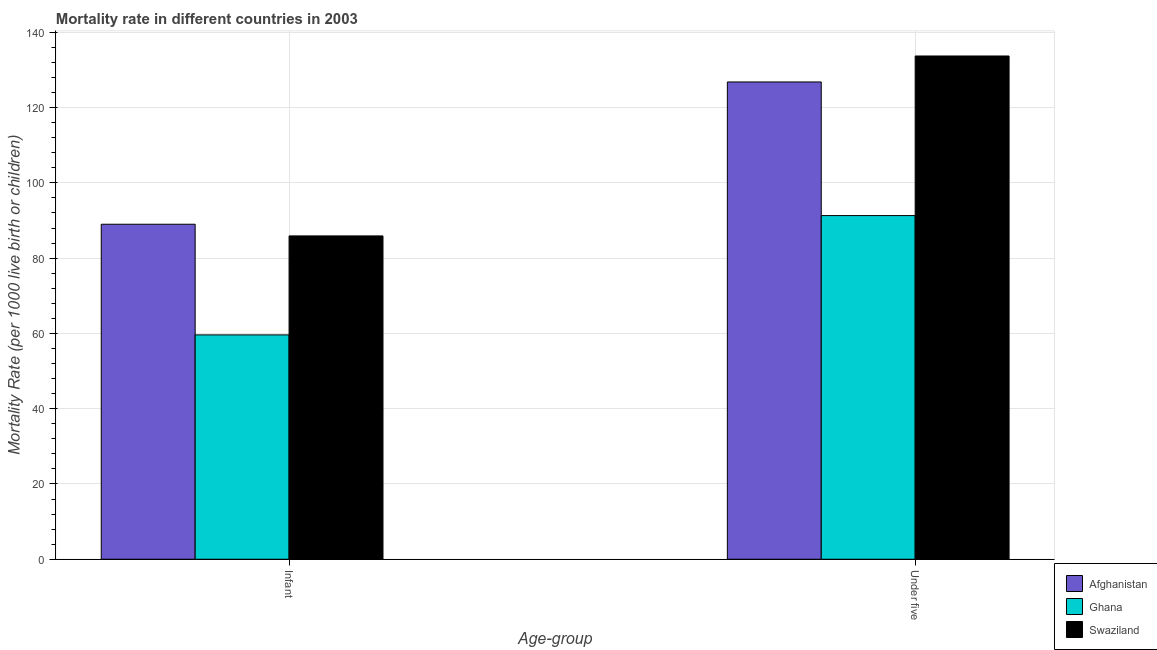How many different coloured bars are there?
Give a very brief answer. 3. Are the number of bars on each tick of the X-axis equal?
Offer a very short reply. Yes. How many bars are there on the 2nd tick from the left?
Ensure brevity in your answer.  3. How many bars are there on the 2nd tick from the right?
Your answer should be compact. 3. What is the label of the 1st group of bars from the left?
Give a very brief answer. Infant. What is the infant mortality rate in Ghana?
Your response must be concise. 59.6. Across all countries, what is the maximum under-5 mortality rate?
Offer a terse response. 133.7. Across all countries, what is the minimum infant mortality rate?
Offer a very short reply. 59.6. In which country was the under-5 mortality rate maximum?
Your answer should be compact. Swaziland. In which country was the infant mortality rate minimum?
Keep it short and to the point. Ghana. What is the total under-5 mortality rate in the graph?
Your response must be concise. 351.8. What is the difference between the infant mortality rate in Afghanistan and that in Ghana?
Your answer should be compact. 29.4. What is the difference between the infant mortality rate in Afghanistan and the under-5 mortality rate in Swaziland?
Ensure brevity in your answer.  -44.7. What is the average under-5 mortality rate per country?
Your answer should be very brief. 117.27. What is the difference between the under-5 mortality rate and infant mortality rate in Ghana?
Your answer should be compact. 31.7. In how many countries, is the under-5 mortality rate greater than 48 ?
Keep it short and to the point. 3. What is the ratio of the under-5 mortality rate in Swaziland to that in Afghanistan?
Provide a succinct answer. 1.05. Is the infant mortality rate in Ghana less than that in Afghanistan?
Make the answer very short. Yes. In how many countries, is the under-5 mortality rate greater than the average under-5 mortality rate taken over all countries?
Provide a short and direct response. 2. What does the 3rd bar from the left in Under five represents?
Keep it short and to the point. Swaziland. What does the 1st bar from the right in Under five represents?
Keep it short and to the point. Swaziland. How many bars are there?
Give a very brief answer. 6. Are all the bars in the graph horizontal?
Ensure brevity in your answer.  No. How many countries are there in the graph?
Offer a terse response. 3. What is the difference between two consecutive major ticks on the Y-axis?
Your response must be concise. 20. Does the graph contain any zero values?
Give a very brief answer. No. Does the graph contain grids?
Give a very brief answer. Yes. What is the title of the graph?
Provide a succinct answer. Mortality rate in different countries in 2003. Does "Italy" appear as one of the legend labels in the graph?
Give a very brief answer. No. What is the label or title of the X-axis?
Give a very brief answer. Age-group. What is the label or title of the Y-axis?
Provide a succinct answer. Mortality Rate (per 1000 live birth or children). What is the Mortality Rate (per 1000 live birth or children) of Afghanistan in Infant?
Ensure brevity in your answer.  89. What is the Mortality Rate (per 1000 live birth or children) in Ghana in Infant?
Give a very brief answer. 59.6. What is the Mortality Rate (per 1000 live birth or children) in Swaziland in Infant?
Your answer should be very brief. 85.9. What is the Mortality Rate (per 1000 live birth or children) in Afghanistan in Under five?
Keep it short and to the point. 126.8. What is the Mortality Rate (per 1000 live birth or children) of Ghana in Under five?
Ensure brevity in your answer.  91.3. What is the Mortality Rate (per 1000 live birth or children) in Swaziland in Under five?
Keep it short and to the point. 133.7. Across all Age-group, what is the maximum Mortality Rate (per 1000 live birth or children) in Afghanistan?
Offer a terse response. 126.8. Across all Age-group, what is the maximum Mortality Rate (per 1000 live birth or children) in Ghana?
Provide a short and direct response. 91.3. Across all Age-group, what is the maximum Mortality Rate (per 1000 live birth or children) in Swaziland?
Provide a short and direct response. 133.7. Across all Age-group, what is the minimum Mortality Rate (per 1000 live birth or children) of Afghanistan?
Provide a succinct answer. 89. Across all Age-group, what is the minimum Mortality Rate (per 1000 live birth or children) in Ghana?
Your answer should be compact. 59.6. Across all Age-group, what is the minimum Mortality Rate (per 1000 live birth or children) in Swaziland?
Provide a succinct answer. 85.9. What is the total Mortality Rate (per 1000 live birth or children) in Afghanistan in the graph?
Provide a short and direct response. 215.8. What is the total Mortality Rate (per 1000 live birth or children) of Ghana in the graph?
Provide a succinct answer. 150.9. What is the total Mortality Rate (per 1000 live birth or children) of Swaziland in the graph?
Your answer should be compact. 219.6. What is the difference between the Mortality Rate (per 1000 live birth or children) of Afghanistan in Infant and that in Under five?
Keep it short and to the point. -37.8. What is the difference between the Mortality Rate (per 1000 live birth or children) in Ghana in Infant and that in Under five?
Your response must be concise. -31.7. What is the difference between the Mortality Rate (per 1000 live birth or children) in Swaziland in Infant and that in Under five?
Your answer should be very brief. -47.8. What is the difference between the Mortality Rate (per 1000 live birth or children) in Afghanistan in Infant and the Mortality Rate (per 1000 live birth or children) in Swaziland in Under five?
Your answer should be compact. -44.7. What is the difference between the Mortality Rate (per 1000 live birth or children) of Ghana in Infant and the Mortality Rate (per 1000 live birth or children) of Swaziland in Under five?
Your response must be concise. -74.1. What is the average Mortality Rate (per 1000 live birth or children) in Afghanistan per Age-group?
Make the answer very short. 107.9. What is the average Mortality Rate (per 1000 live birth or children) in Ghana per Age-group?
Offer a terse response. 75.45. What is the average Mortality Rate (per 1000 live birth or children) of Swaziland per Age-group?
Ensure brevity in your answer.  109.8. What is the difference between the Mortality Rate (per 1000 live birth or children) in Afghanistan and Mortality Rate (per 1000 live birth or children) in Ghana in Infant?
Keep it short and to the point. 29.4. What is the difference between the Mortality Rate (per 1000 live birth or children) in Afghanistan and Mortality Rate (per 1000 live birth or children) in Swaziland in Infant?
Give a very brief answer. 3.1. What is the difference between the Mortality Rate (per 1000 live birth or children) in Ghana and Mortality Rate (per 1000 live birth or children) in Swaziland in Infant?
Keep it short and to the point. -26.3. What is the difference between the Mortality Rate (per 1000 live birth or children) of Afghanistan and Mortality Rate (per 1000 live birth or children) of Ghana in Under five?
Give a very brief answer. 35.5. What is the difference between the Mortality Rate (per 1000 live birth or children) in Afghanistan and Mortality Rate (per 1000 live birth or children) in Swaziland in Under five?
Offer a terse response. -6.9. What is the difference between the Mortality Rate (per 1000 live birth or children) of Ghana and Mortality Rate (per 1000 live birth or children) of Swaziland in Under five?
Your answer should be compact. -42.4. What is the ratio of the Mortality Rate (per 1000 live birth or children) in Afghanistan in Infant to that in Under five?
Your answer should be very brief. 0.7. What is the ratio of the Mortality Rate (per 1000 live birth or children) in Ghana in Infant to that in Under five?
Make the answer very short. 0.65. What is the ratio of the Mortality Rate (per 1000 live birth or children) in Swaziland in Infant to that in Under five?
Ensure brevity in your answer.  0.64. What is the difference between the highest and the second highest Mortality Rate (per 1000 live birth or children) of Afghanistan?
Keep it short and to the point. 37.8. What is the difference between the highest and the second highest Mortality Rate (per 1000 live birth or children) of Ghana?
Ensure brevity in your answer.  31.7. What is the difference between the highest and the second highest Mortality Rate (per 1000 live birth or children) in Swaziland?
Keep it short and to the point. 47.8. What is the difference between the highest and the lowest Mortality Rate (per 1000 live birth or children) of Afghanistan?
Provide a short and direct response. 37.8. What is the difference between the highest and the lowest Mortality Rate (per 1000 live birth or children) in Ghana?
Provide a short and direct response. 31.7. What is the difference between the highest and the lowest Mortality Rate (per 1000 live birth or children) in Swaziland?
Your response must be concise. 47.8. 